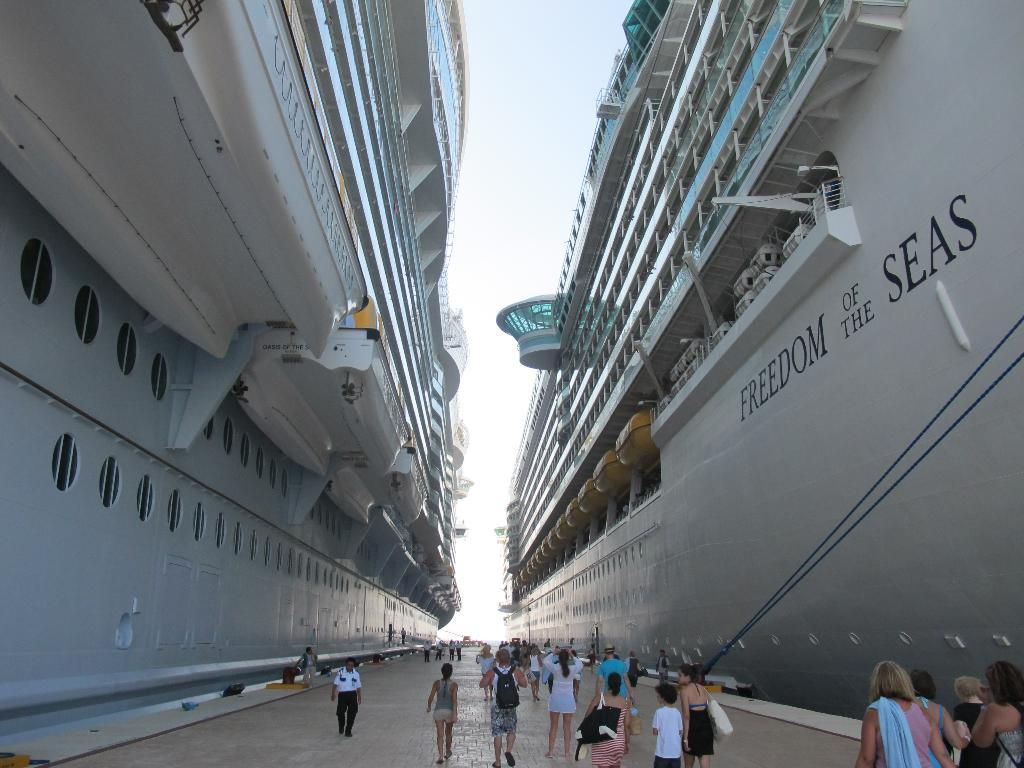<image>
Write a terse but informative summary of the picture. the word seas on the side of a large ship 